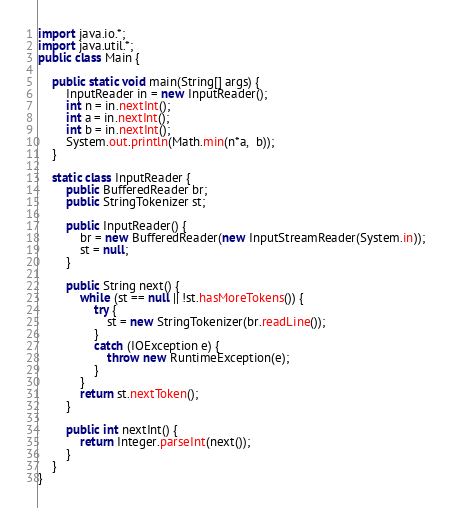Convert code to text. <code><loc_0><loc_0><loc_500><loc_500><_Java_>import java.io.*;
import java.util.*;
public class Main {
	
	public static void main(String[] args) {
		InputReader in = new InputReader();
		int n = in.nextInt();
		int a = in.nextInt();
		int b = in.nextInt();
		System.out.println(Math.min(n*a,  b));
	}

	static class InputReader {
		public BufferedReader br;
		public StringTokenizer st;
		
		public InputReader() {
			br = new BufferedReader(new InputStreamReader(System.in));
			st = null;
		}
		
		public String next() {
			while (st == null || !st.hasMoreTokens()) {
				try {
					st = new StringTokenizer(br.readLine());
				}
				catch (IOException e) {
					throw new RuntimeException(e);
				}
			}
			return st.nextToken();
		}
		
		public int nextInt() {
			return Integer.parseInt(next());
		}
	}
}</code> 